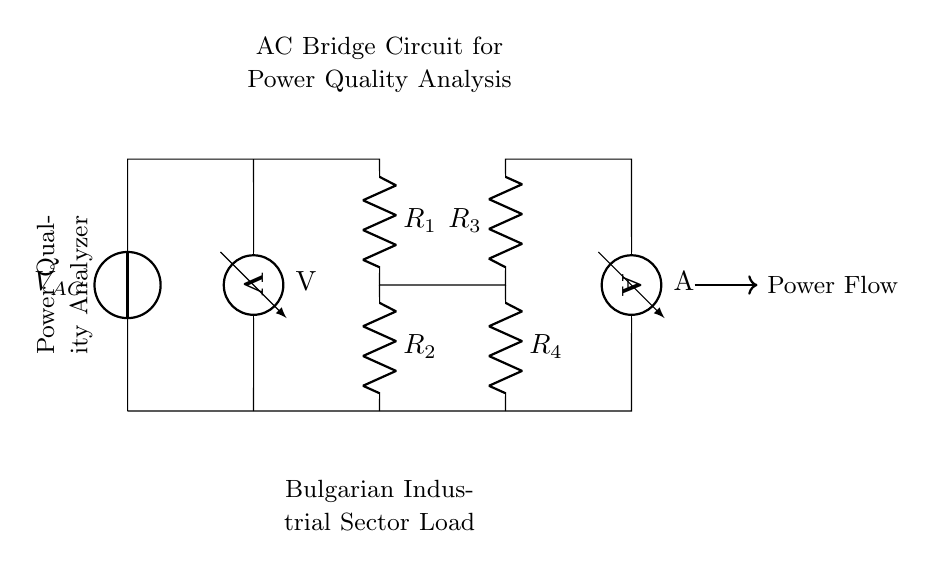What is the power source in this circuit? The circuit diagram shows a voltage source labeled with a symbol for alternating current, indicating that V_AC is the power source.
Answer: V_AC What type of components are R1 and R2? Both R1 and R2 are resistors, which can be identified from the circuit symbols used for these components.
Answer: Resistors How many resistors are in total in this circuit? By examining the diagram, you can count four resistors labeled as R1, R2, R3, and R4.
Answer: Four What does the ammeter measure in this circuit? The ammeter is placed in series, and it is used to measure the current flowing through the circuit.
Answer: Current What is the primary function of the power quality analyzer? The label in the diagram indicates that the component's purpose is to analyze the power quality, meaning it assesses factors such as voltage, current, and harmonics in the circuit.
Answer: Analyze power quality How many voltage and current measurement instruments are present in the circuit? There is one voltmeter and one ammeter present, as indicated in their respective labels within the circuit diagram.
Answer: Two Why are there two paths for current flow in this circuit? The presence of two resistors in parallel (R3 and R4) and two resistors in series (R1 and R2) creates multiple paths, allowing for analyzing different aspects of power quality simultaneously.
Answer: To analyze power quality 